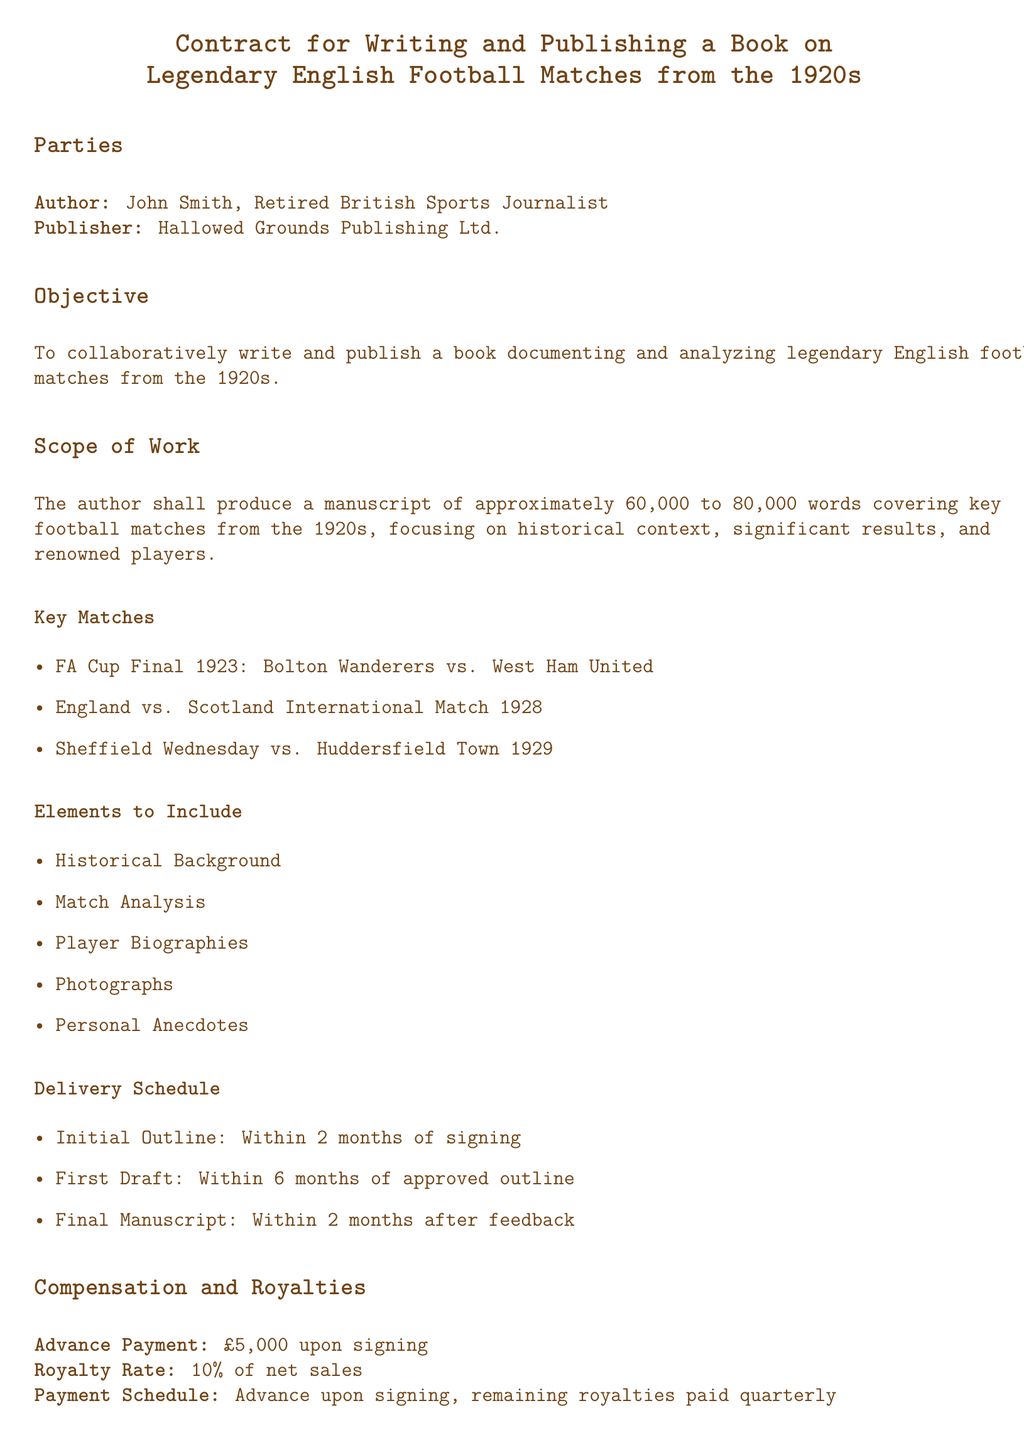What is the title of the contract? The title of the contract is explicitly stated at the beginning, summarizing its purpose.
Answer: Contract for Writing and Publishing a Book on Legendary English Football Matches from the 1920s Who is the author of the book? The document specifies the name and profession of the author under the Parties section.
Answer: John Smith What is the advance payment amount? The advance payment is clearly indicated under the Compensation and Royalties section.
Answer: £5,000 How many key matches are listed in the Scope of Work? The number of key matches is determined by counting the items in the Key Matches list.
Answer: 3 What is the royalty rate on net sales? The royalty rate is stated in the Compensation and Royalties section, providing financial details for the author's earnings.
Answer: 10% What is the deadline for the initial outline? The timeline for the initial outline is provided under the Delivery Schedule section.
Answer: Within 2 months of signing Under what condition may the publisher terminate the contract? The termination conditions specify the publisher's rights and reasons for potential termination.
Answer: If author fails to meet deadlines What rights are granted to the publisher? The document outlines what rights are licensed to the publisher under the Copyright and Rights section.
Answer: Exclusive worldwide license 